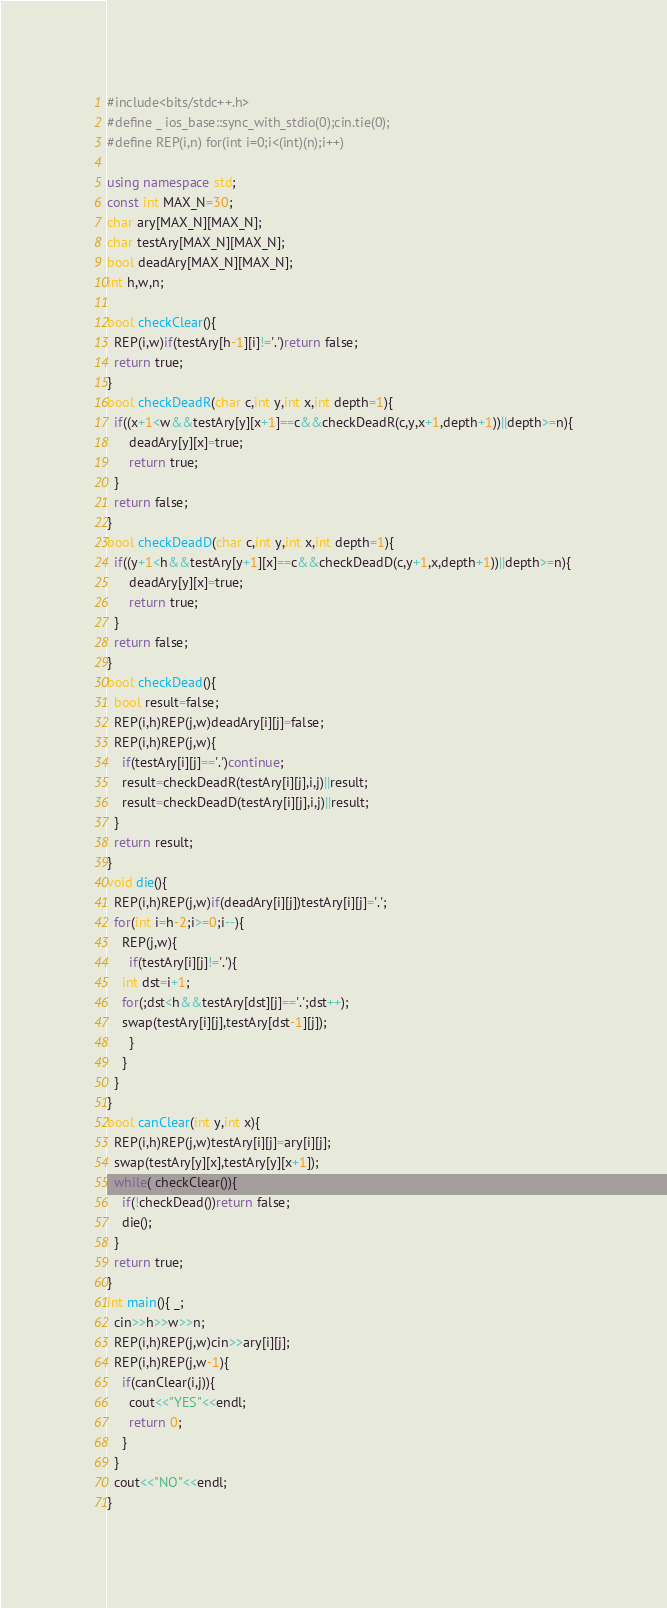Convert code to text. <code><loc_0><loc_0><loc_500><loc_500><_C++_>#include<bits/stdc++.h>
#define _ ios_base::sync_with_stdio(0);cin.tie(0);
#define REP(i,n) for(int i=0;i<(int)(n);i++)

using namespace std;
const int MAX_N=30;
char ary[MAX_N][MAX_N];
char testAry[MAX_N][MAX_N];
bool deadAry[MAX_N][MAX_N];
int h,w,n;

bool checkClear(){
  REP(i,w)if(testAry[h-1][i]!='.')return false;
  return true;
}
bool checkDeadR(char c,int y,int x,int depth=1){
  if((x+1<w&&testAry[y][x+1]==c&&checkDeadR(c,y,x+1,depth+1))||depth>=n){
      deadAry[y][x]=true;
      return true;
  }
  return false;
}
bool checkDeadD(char c,int y,int x,int depth=1){
  if((y+1<h&&testAry[y+1][x]==c&&checkDeadD(c,y+1,x,depth+1))||depth>=n){
      deadAry[y][x]=true;
      return true;
  }
  return false;
}
bool checkDead(){
  bool result=false;
  REP(i,h)REP(j,w)deadAry[i][j]=false;
  REP(i,h)REP(j,w){
    if(testAry[i][j]=='.')continue;
    result=checkDeadR(testAry[i][j],i,j)||result;
    result=checkDeadD(testAry[i][j],i,j)||result;
  }
  return result;
}
void die(){
  REP(i,h)REP(j,w)if(deadAry[i][j])testAry[i][j]='.';
  for(int i=h-2;i>=0;i--){
    REP(j,w){
      if(testAry[i][j]!='.'){
	int dst=i+1;
	for(;dst<h&&testAry[dst][j]=='.';dst++);
	swap(testAry[i][j],testAry[dst-1][j]);
      }
    }
  }
}
bool canClear(int y,int x){
  REP(i,h)REP(j,w)testAry[i][j]=ary[i][j];
  swap(testAry[y][x],testAry[y][x+1]);
  while(!checkClear()){
    if(!checkDead())return false;
    die();
  }
  return true;
}
int main(){ _;
  cin>>h>>w>>n;
  REP(i,h)REP(j,w)cin>>ary[i][j];
  REP(i,h)REP(j,w-1){
    if(canClear(i,j)){
      cout<<"YES"<<endl;
      return 0;
    }
  }
  cout<<"NO"<<endl;
}</code> 